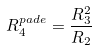<formula> <loc_0><loc_0><loc_500><loc_500>R _ { 4 } ^ { p a d e } = \frac { R _ { 3 } ^ { 2 } } { R _ { 2 } }</formula> 